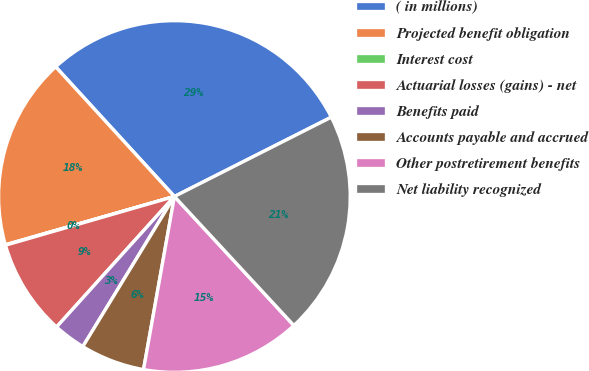Convert chart to OTSL. <chart><loc_0><loc_0><loc_500><loc_500><pie_chart><fcel>( in millions)<fcel>Projected benefit obligation<fcel>Interest cost<fcel>Actuarial losses (gains) - net<fcel>Benefits paid<fcel>Accounts payable and accrued<fcel>Other postretirement benefits<fcel>Net liability recognized<nl><fcel>29.35%<fcel>17.63%<fcel>0.04%<fcel>8.84%<fcel>2.97%<fcel>5.91%<fcel>14.7%<fcel>20.56%<nl></chart> 